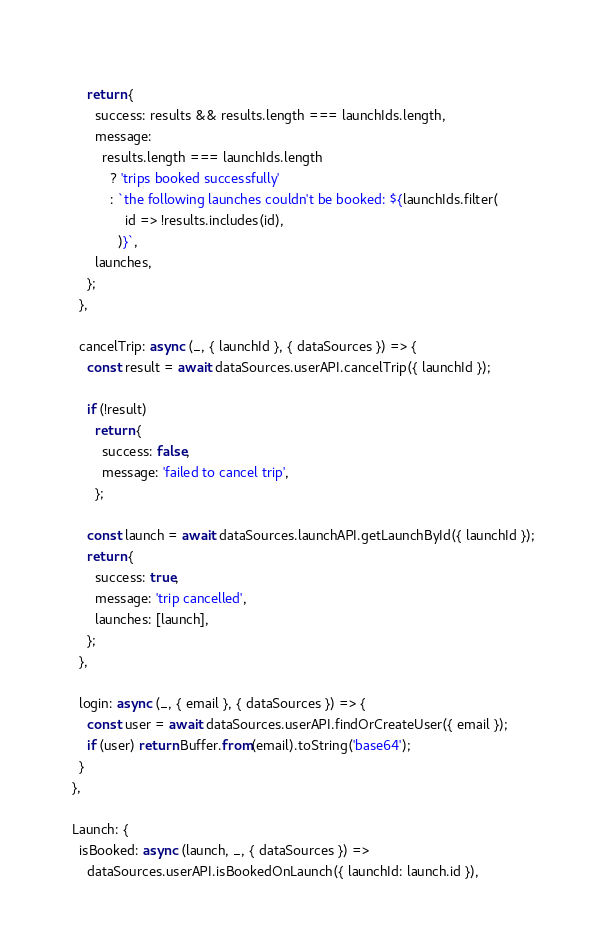<code> <loc_0><loc_0><loc_500><loc_500><_JavaScript_>  
      return {
        success: results && results.length === launchIds.length,
        message:
          results.length === launchIds.length
            ? 'trips booked successfully'
            : `the following launches couldn't be booked: ${launchIds.filter(
                id => !results.includes(id),
              )}`,
        launches,
      };
    },

    cancelTrip: async (_, { launchId }, { dataSources }) => {
      const result = await dataSources.userAPI.cancelTrip({ launchId });
  
      if (!result)
        return {
          success: false,
          message: 'failed to cancel trip',
        };
  
      const launch = await dataSources.launchAPI.getLaunchById({ launchId });
      return {
        success: true,
        message: 'trip cancelled',
        launches: [launch],
      };
    },
    
    login: async (_, { email }, { dataSources }) => {
      const user = await dataSources.userAPI.findOrCreateUser({ email });
      if (user) return Buffer.from(email).toString('base64');
    }
  },

  Launch: {
    isBooked: async (launch, _, { dataSources }) =>
      dataSources.userAPI.isBookedOnLaunch({ launchId: launch.id }),</code> 